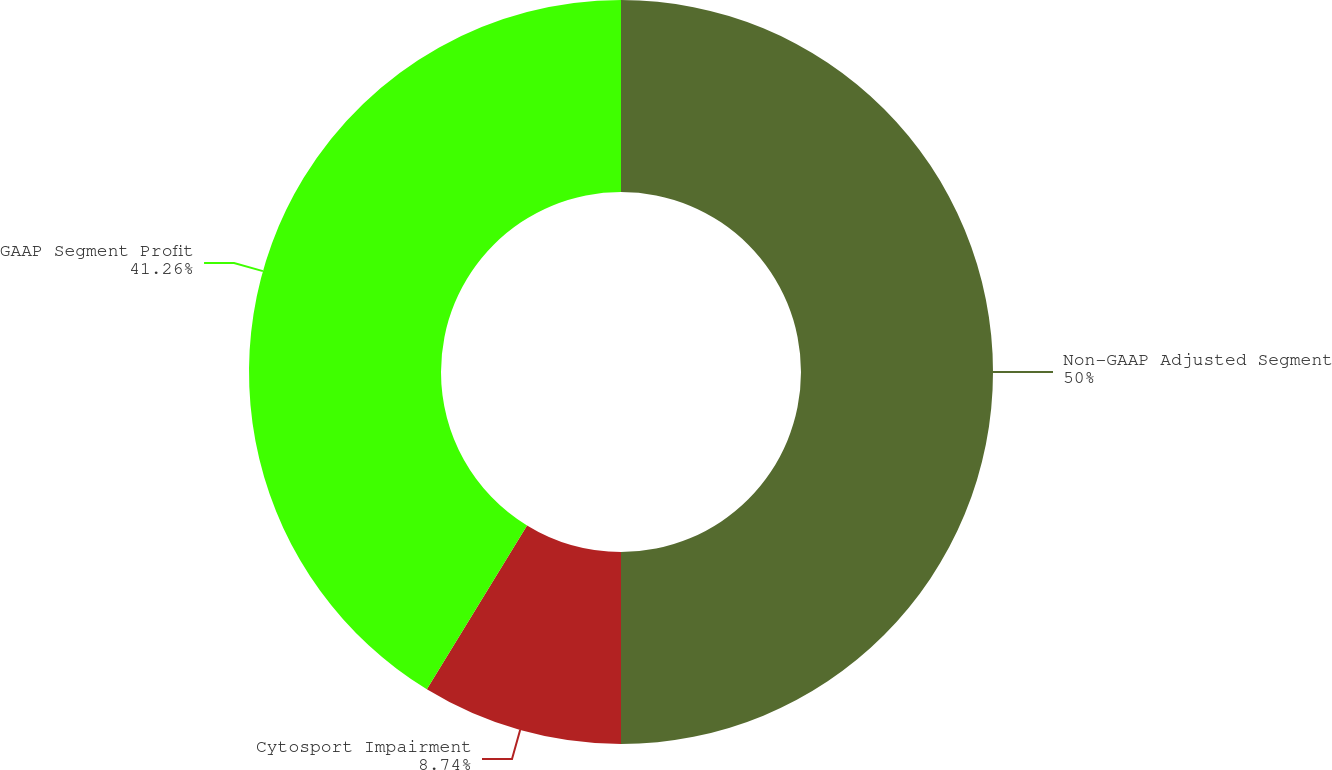Convert chart. <chart><loc_0><loc_0><loc_500><loc_500><pie_chart><fcel>Non-GAAP Adjusted Segment<fcel>Cytosport Impairment<fcel>GAAP Segment Profit<nl><fcel>50.0%<fcel>8.74%<fcel>41.26%<nl></chart> 